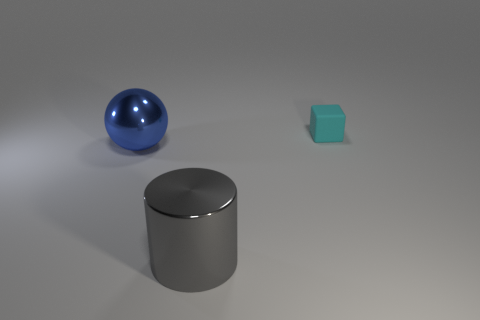Add 1 tiny cyan matte blocks. How many objects exist? 4 Subtract all blue cylinders. How many green spheres are left? 0 Add 3 small gray metal balls. How many small gray metal balls exist? 3 Subtract 1 gray cylinders. How many objects are left? 2 Subtract 1 cubes. How many cubes are left? 0 Subtract all purple blocks. Subtract all blue cylinders. How many blocks are left? 1 Subtract all gray cylinders. Subtract all big things. How many objects are left? 0 Add 3 large metal things. How many large metal things are left? 5 